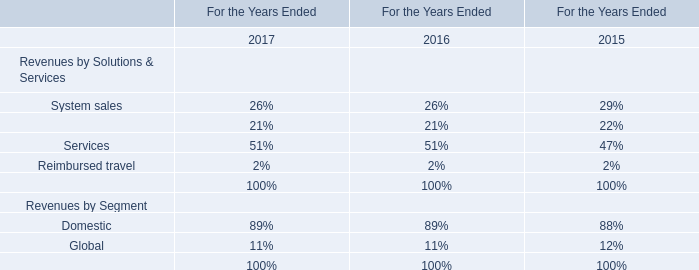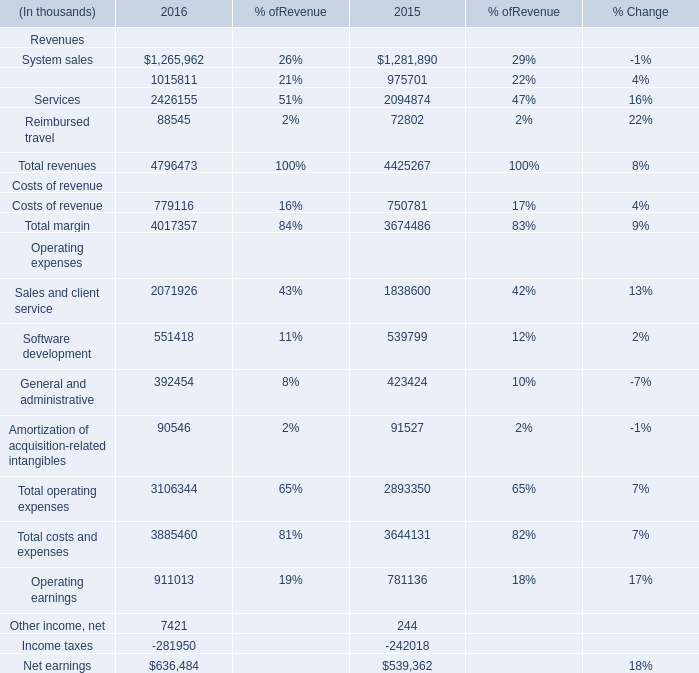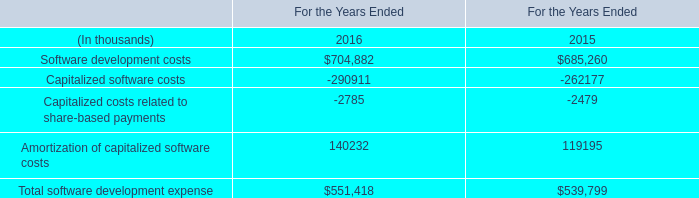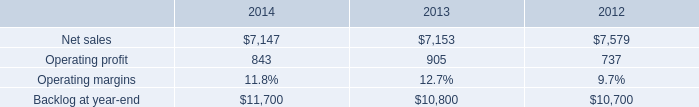what is the growth rate in net sales for mst in 2014? 
Computations: ((7147 - 7153) / 7153)
Answer: -0.00084. 